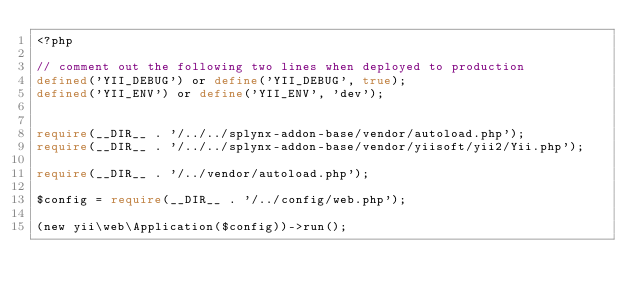<code> <loc_0><loc_0><loc_500><loc_500><_PHP_><?php

// comment out the following two lines when deployed to production
defined('YII_DEBUG') or define('YII_DEBUG', true);
defined('YII_ENV') or define('YII_ENV', 'dev');


require(__DIR__ . '/../../splynx-addon-base/vendor/autoload.php');
require(__DIR__ . '/../../splynx-addon-base/vendor/yiisoft/yii2/Yii.php');

require(__DIR__ . '/../vendor/autoload.php');

$config = require(__DIR__ . '/../config/web.php');

(new yii\web\Application($config))->run();
</code> 